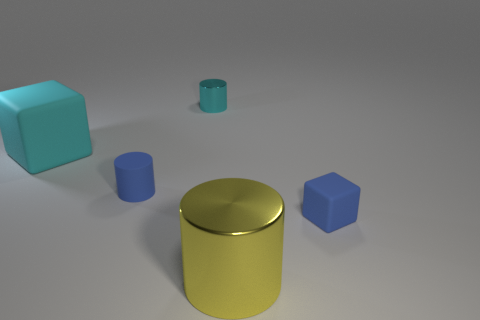Add 2 tiny rubber cylinders. How many objects exist? 7 Subtract all cylinders. How many objects are left? 2 Subtract all blue things. Subtract all small blue rubber cubes. How many objects are left? 2 Add 2 large yellow cylinders. How many large yellow cylinders are left? 3 Add 5 tiny blocks. How many tiny blocks exist? 6 Subtract 0 gray spheres. How many objects are left? 5 